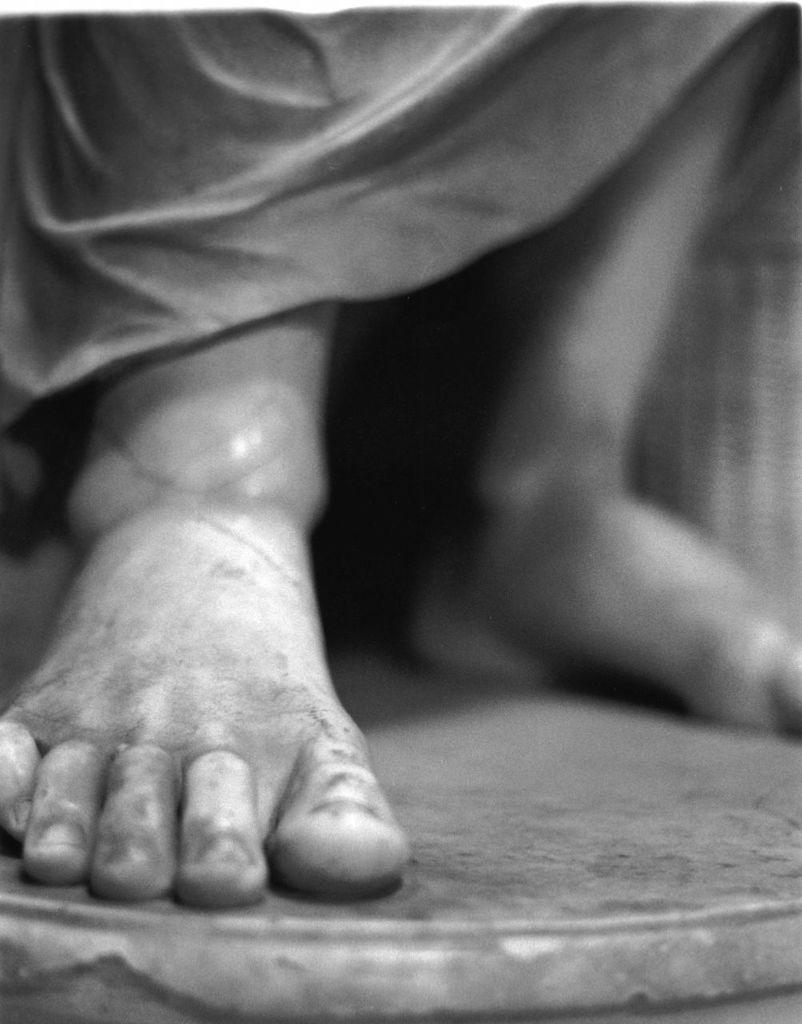What is the color scheme of the image? The image is black and white. What can be seen on the floor in the image? There are two legs visible on the floor. What type of loaf is sitting on the chair in the image? There is no chair or loaf present in the image; it only features two legs on the floor. Can you describe the scarecrow's clothing in the image? There is no scarecrow present in the image; it only features two legs on the floor. 